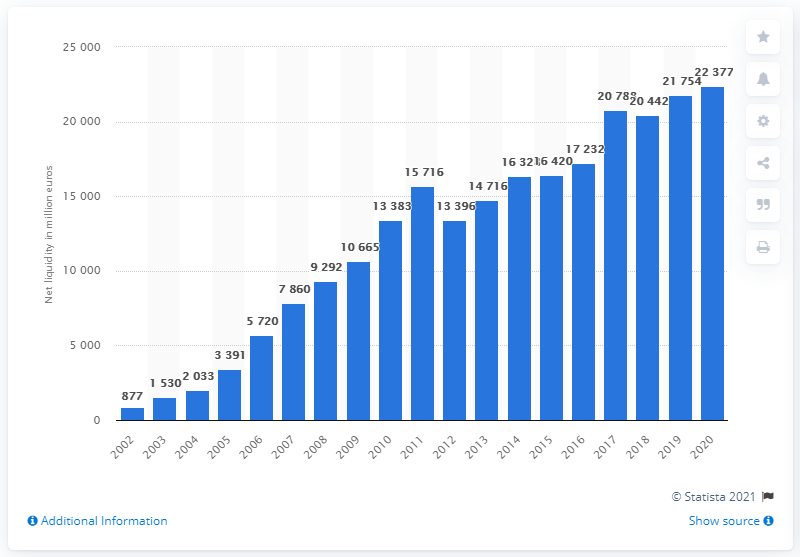Identify some key points in this picture. In the year 2020, Audi's net liquidity came to an end. Audi's net liquidity in the fiscal year of 2020 was 22,377. In 2002, Audi's net liquidity was measured. 